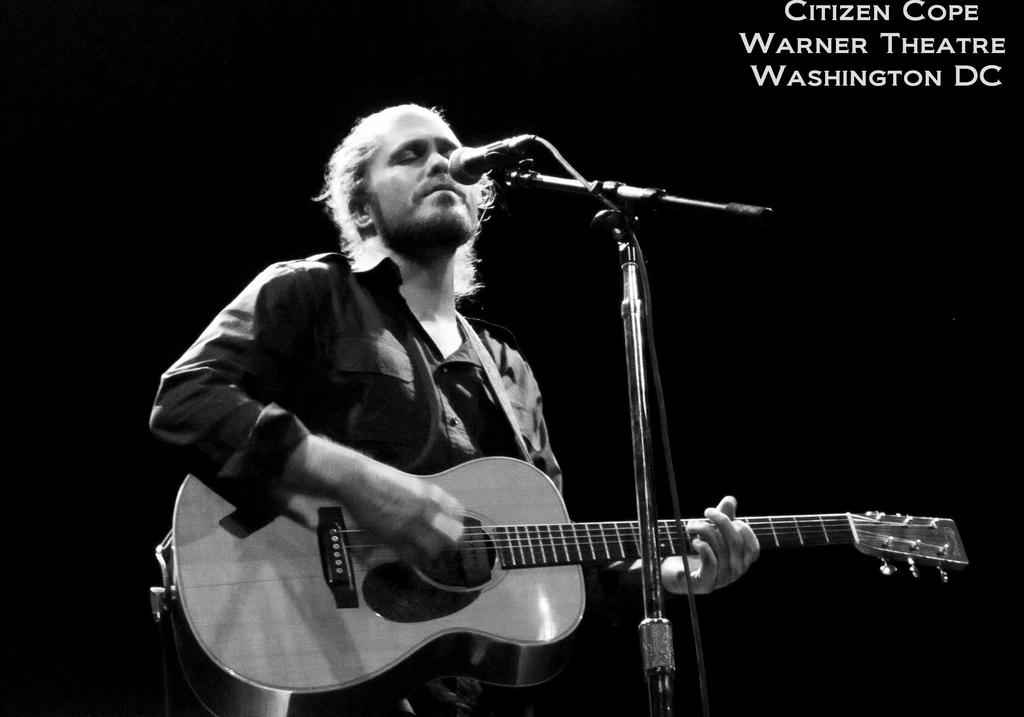Who is the main subject in the image? There is a man in the image. What is the man doing in the image? The man is playing a guitar. What is the man wearing in the image? The man is wearing a shirt. What object is in front of the man? There is a microphone in front of the man. Is the man wearing a mask in the image? There is no mention of a mask in the image, so we cannot determine if the man is wearing one. What direction is the man facing in the image? The provided facts do not mention the direction the man is facing, so we cannot determine his orientation. 